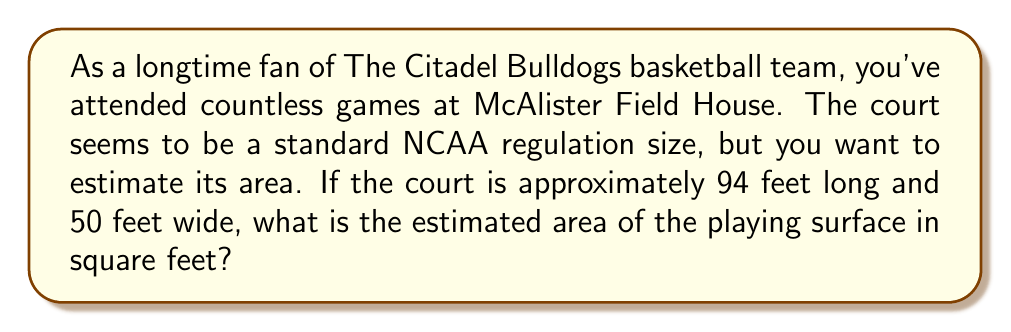Can you solve this math problem? Let's approach this step-by-step:

1) The basketball court is rectangular in shape. The formula for the area of a rectangle is:

   $$A = l \times w$$

   where $A$ is the area, $l$ is the length, and $w$ is the width.

2) We're given that:
   - Length ($l$) ≈ 94 feet
   - Width ($w$) ≈ 50 feet

3) Substituting these values into our formula:

   $$A = 94 \text{ ft} \times 50 \text{ ft}$$

4) Multiplying these numbers:

   $$A = 4,700 \text{ sq ft}$$

5) Therefore, the estimated area of The Citadel's basketball court is 4,700 square feet.

Note: This calculation assumes the entire rectangular area is the playing surface. In reality, there might be some slight differences due to out-of-bounds areas or other factors, but this gives a good estimate of the court size.
Answer: 4,700 sq ft 